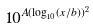Convert formula to latex. <formula><loc_0><loc_0><loc_500><loc_500>1 0 ^ { A ( \log _ { 1 0 } ( x / b ) ) ^ { 2 } }</formula> 